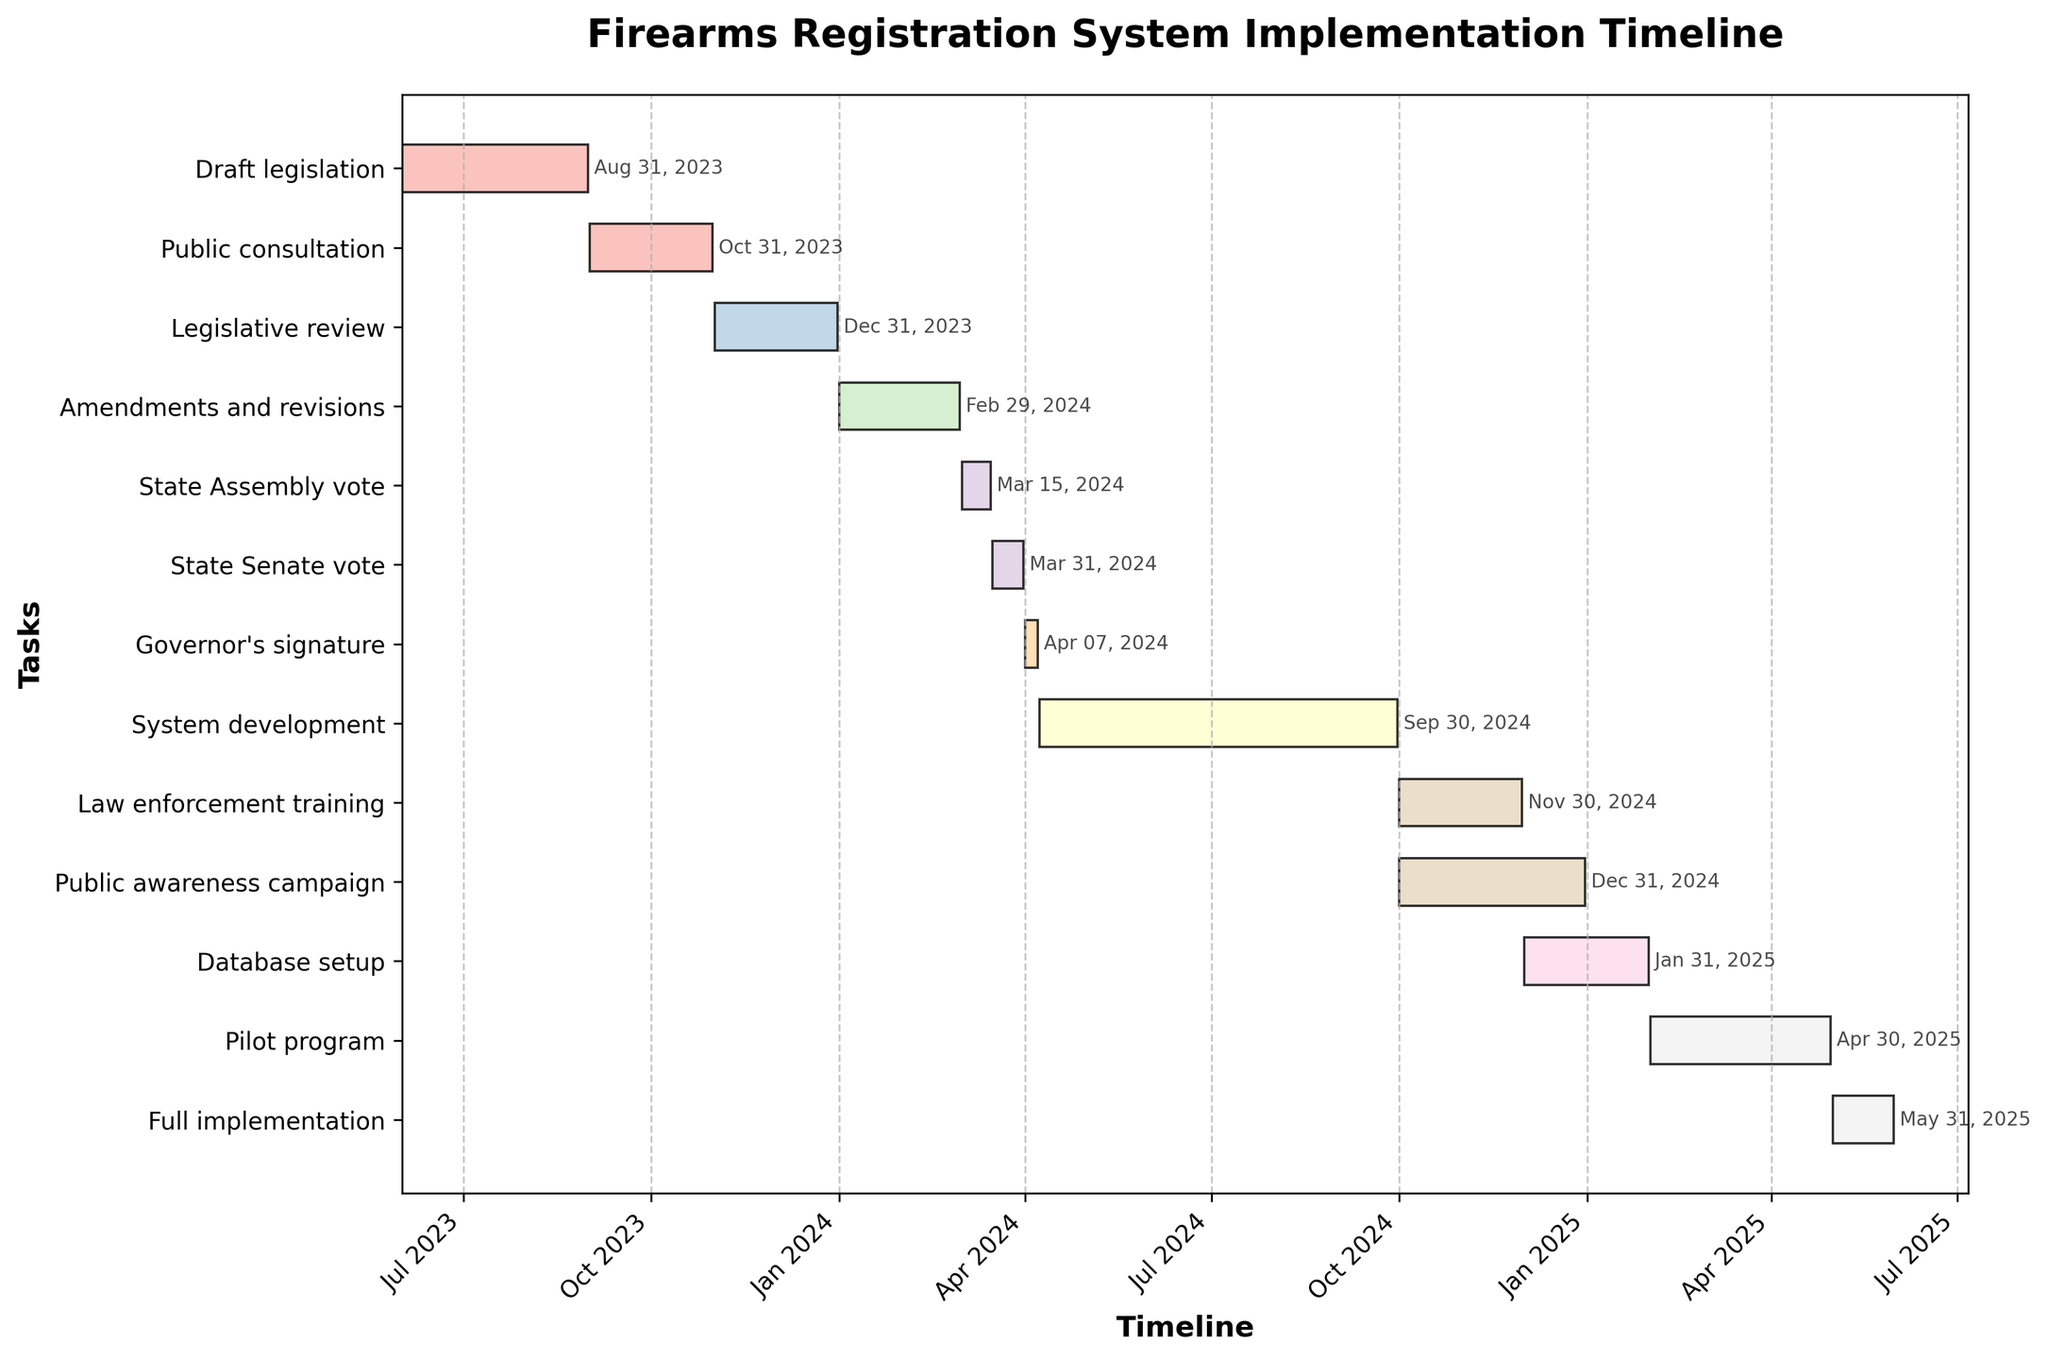What's the title of the figure? The title of the figure is prominently displayed at the top of the chart, indicating the main subject of the visual representation.
Answer: Firearms Registration System Implementation Timeline When does the 'Legislative review' stage start and end? The 'Legislative review' stage is identified as a task on the y-axis. By referring to the horizontal bar corresponding to this task, we can see the start and end dates.
Answer: Nov 1, 2023 to Dec 31, 2023 Which stage follows immediately after 'Public consultation'? To determine which stage follows 'Public consultation,' we look at the order of tasks on the y-axis and observe their start dates. The stage immediately after 'Public consultation' starts on Nov 1, 2023, which is 'Legislative review.'
Answer: Legislative review What's the duration of the 'System development' stage? The horizontal bar representing 'System development' visually indicates its duration. By subtracting the start date (Apr 8, 2024) from the end date (Sep 30, 2024), we can calculate the duration.
Answer: 176 days Are there any tasks that overlap in timeline during 2024? By looking at the timeline and the horizontal bars for each task, we can identify any overlaps in their durations.
Answer: Yes, 'System development' overlaps with 'Governor's signature,' 'Law enforcement training,' and 'Public awareness campaign.' Which stage has the shortest duration? By comparing the lengths of all horizontal bars, the shortest bar represents the task with the shortest duration.
Answer: Governor's signature What is the total span of time from the start of 'Draft legislation' to the end of 'Full implementation'? To find the total span, identify the start date of 'Draft legislation' (Jun 1, 2023) and the end date of 'Full implementation' (May 31, 2025), then calculate the difference between these dates.
Answer: 730 days How many stages start in the year 2024? By examining the start dates of each stage, we count how many stages initiate in the year 2024.
Answer: 8 stages Which tasks run concurrently from October 1, 2024? By checking the start dates of tasks and their durations, we can identify the tasks that start or are in progress on October 1, 2024.
Answer: Law enforcement training, Public awareness campaign, and System development What is the duration of the overlap between 'Law enforcement training' and 'Public awareness campaign'? Both stages overlap starting from Oct 1, 2024. To find the overlap duration, compare their end dates. 'Law enforcement training' ends on Nov 30, 2024, and 'Public awareness campaign' ends on Dec 31, 2024. The overlap is from Oct 1, 2024 to Nov 30, 2024.
Answer: 61 days 